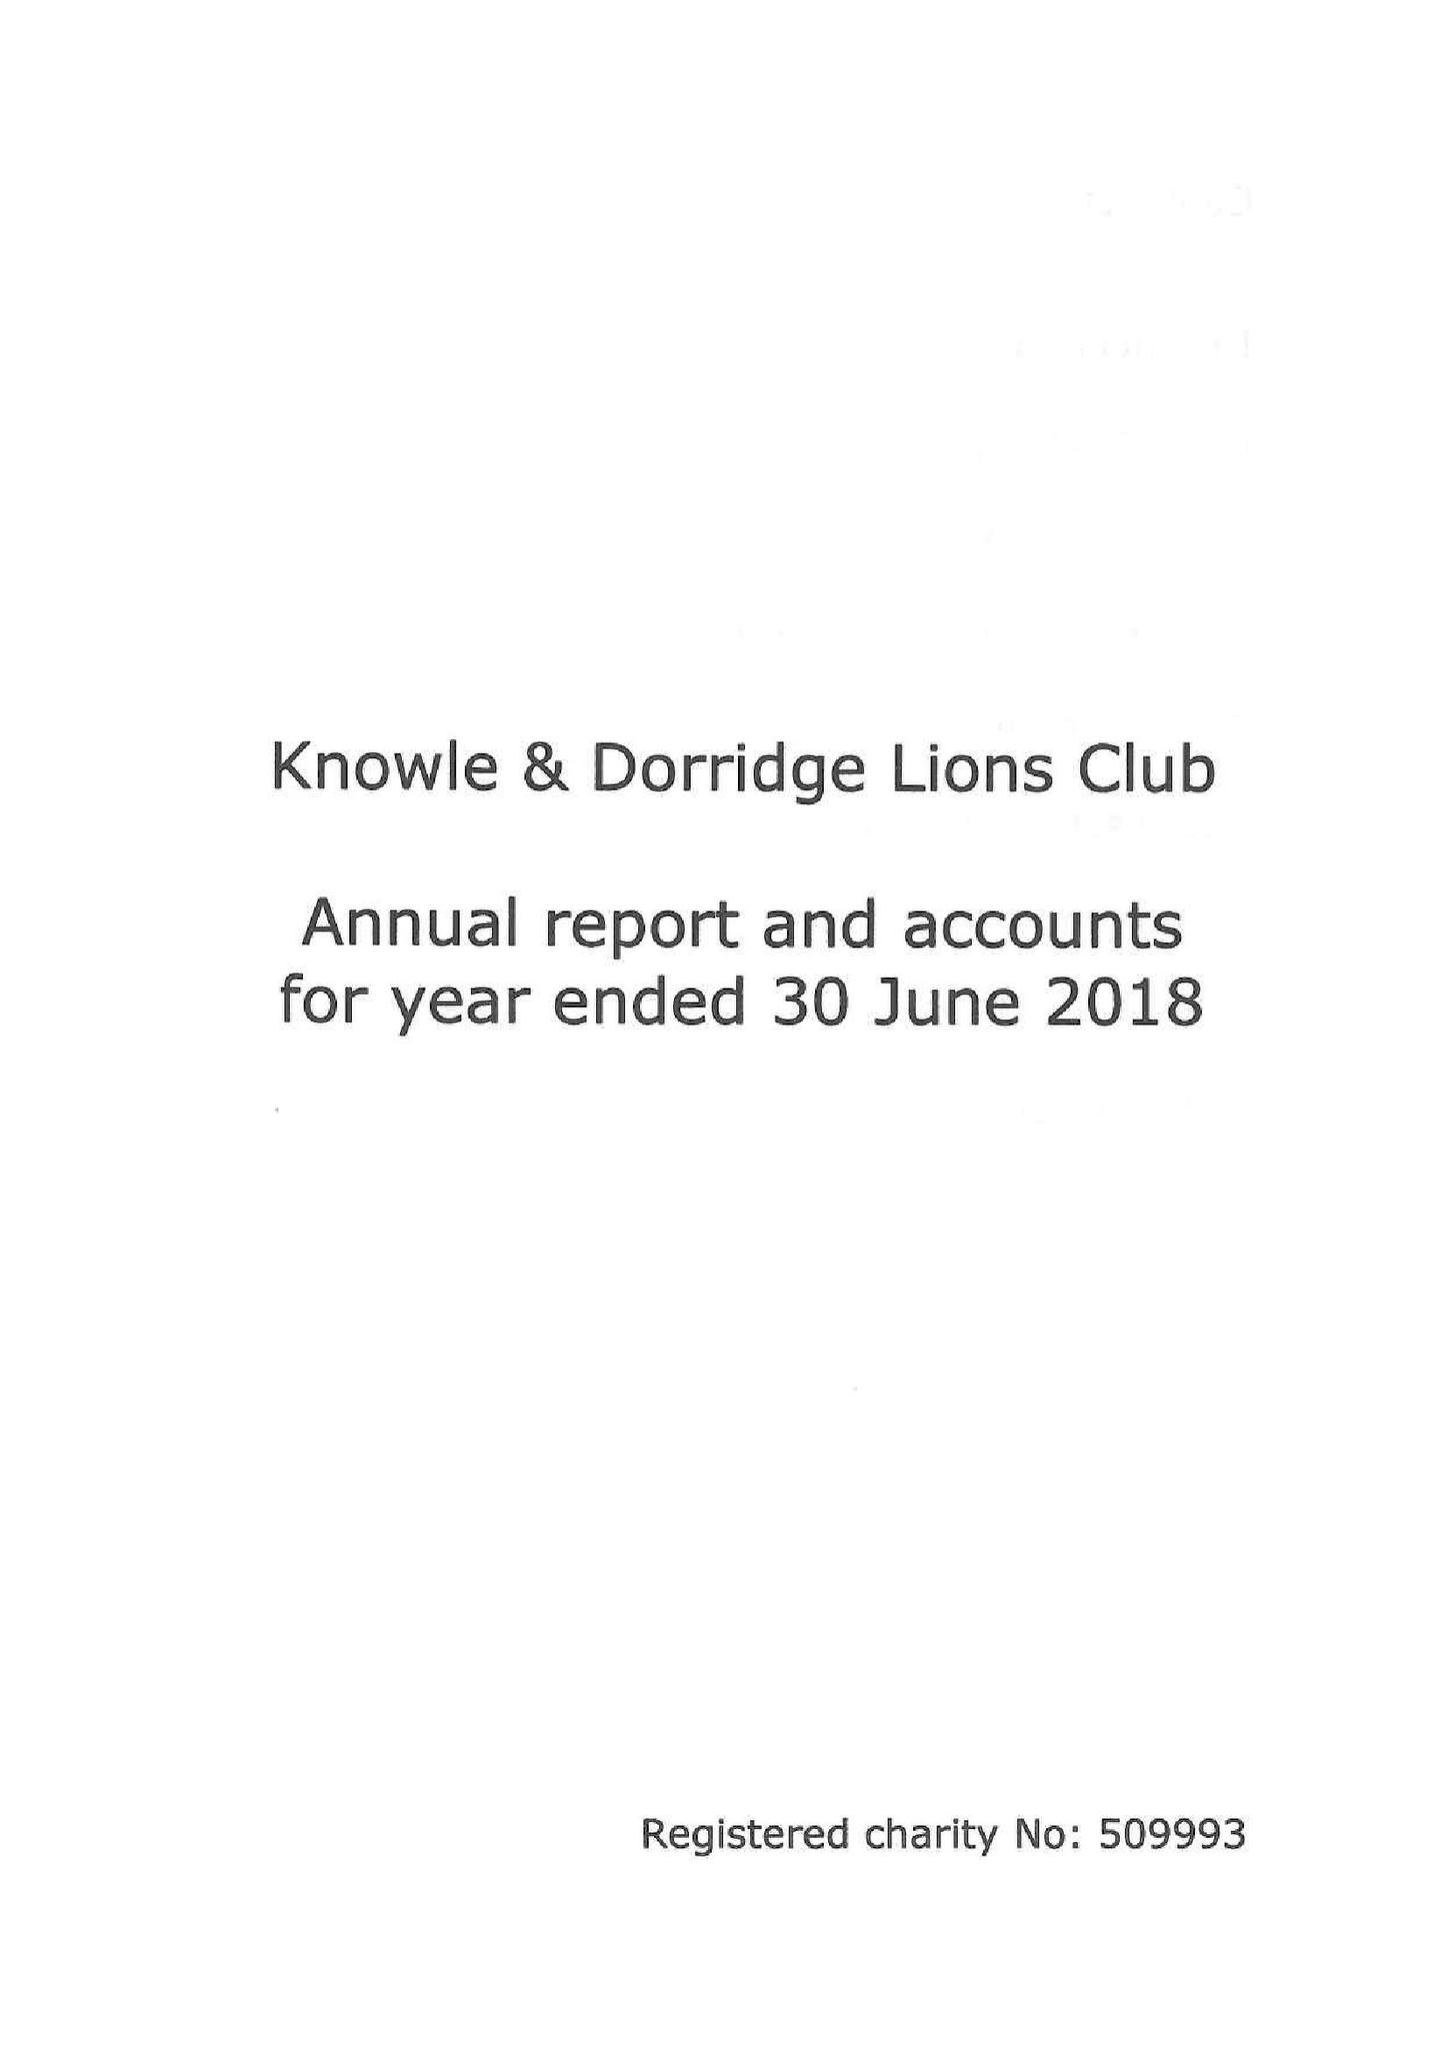What is the value for the report_date?
Answer the question using a single word or phrase. 2018-06-30 